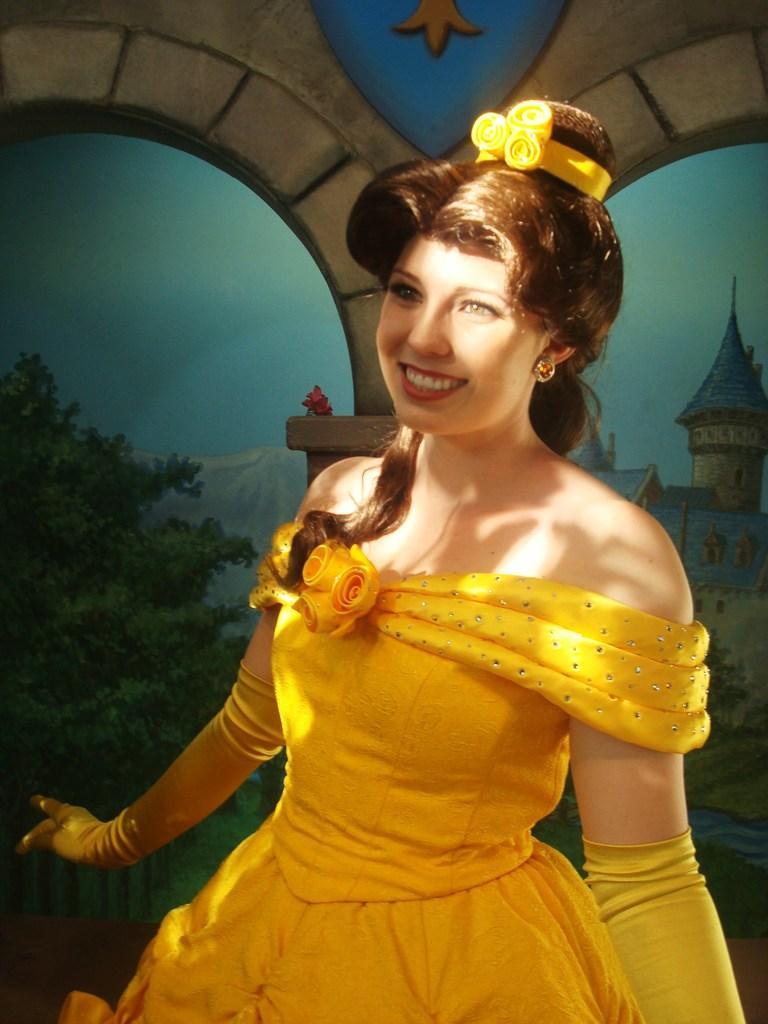In one or two sentences, can you explain what this image depicts? In the image there is a woman standing in yellow dress and behind her there is a wall. 